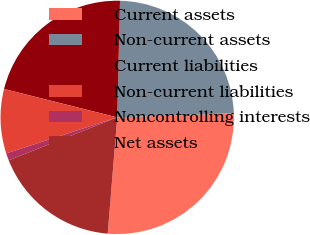<chart> <loc_0><loc_0><loc_500><loc_500><pie_chart><fcel>Current assets<fcel>Non-current assets<fcel>Current liabilities<fcel>Non-current liabilities<fcel>Noncontrolling interests<fcel>Net assets<nl><fcel>26.86%<fcel>24.06%<fcel>21.47%<fcel>8.91%<fcel>1.0%<fcel>17.71%<nl></chart> 